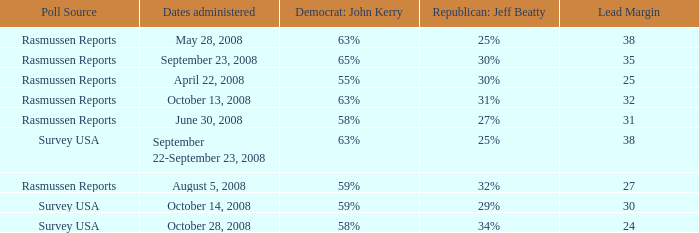What are the dates where democrat john kerry is 63% and poll source is rasmussen reports? October 13, 2008, May 28, 2008. 